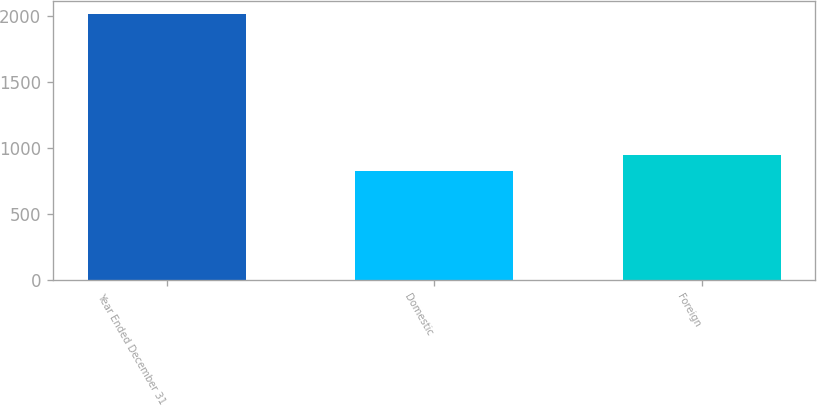<chart> <loc_0><loc_0><loc_500><loc_500><bar_chart><fcel>Year Ended December 31<fcel>Domestic<fcel>Foreign<nl><fcel>2013<fcel>827<fcel>945.6<nl></chart> 